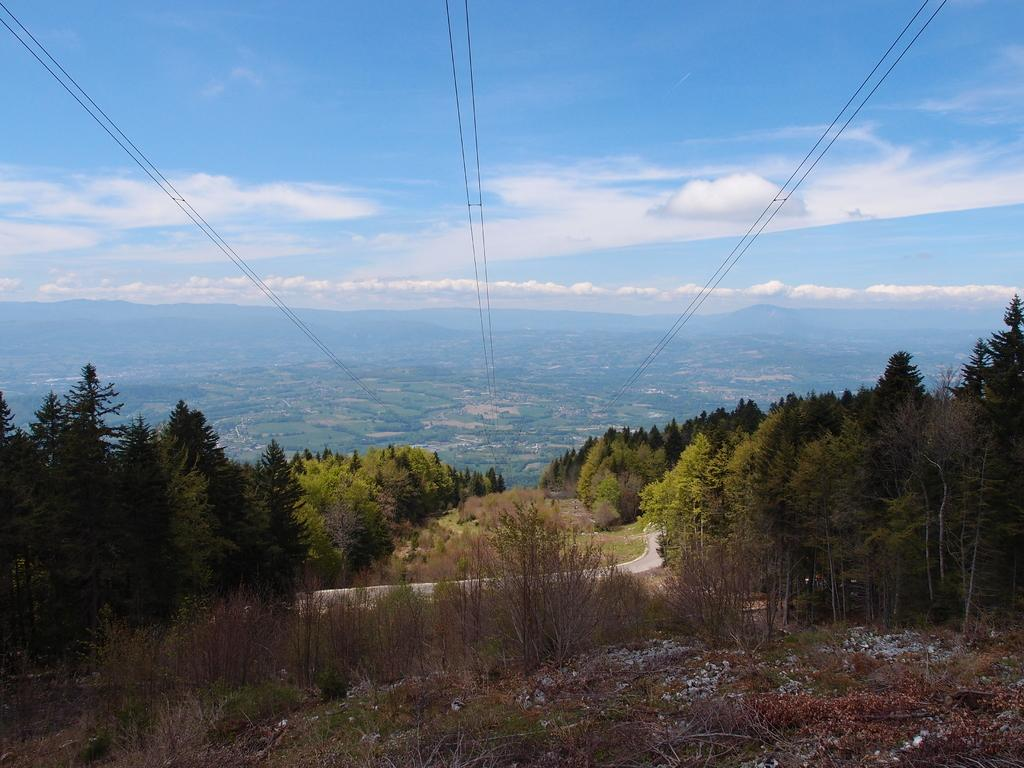What type of vegetation can be seen in the image? There is a group of trees in the image. What can be seen on the ground in the image? There is a pathway in the image. What type of plants are not green in the image? There are dried plants in the image. What is visible in the distance in the image? Mountains and wires are visible in the background of the image. How would you describe the sky in the image? The sky is visible in the background of the image, and it appears cloudy. What is the chance of winning the lottery in the image? There is no mention of a lottery or any chance of winning in the image. What caption would you give to the image? The image does not have a caption, so it's not possible to provide one. 